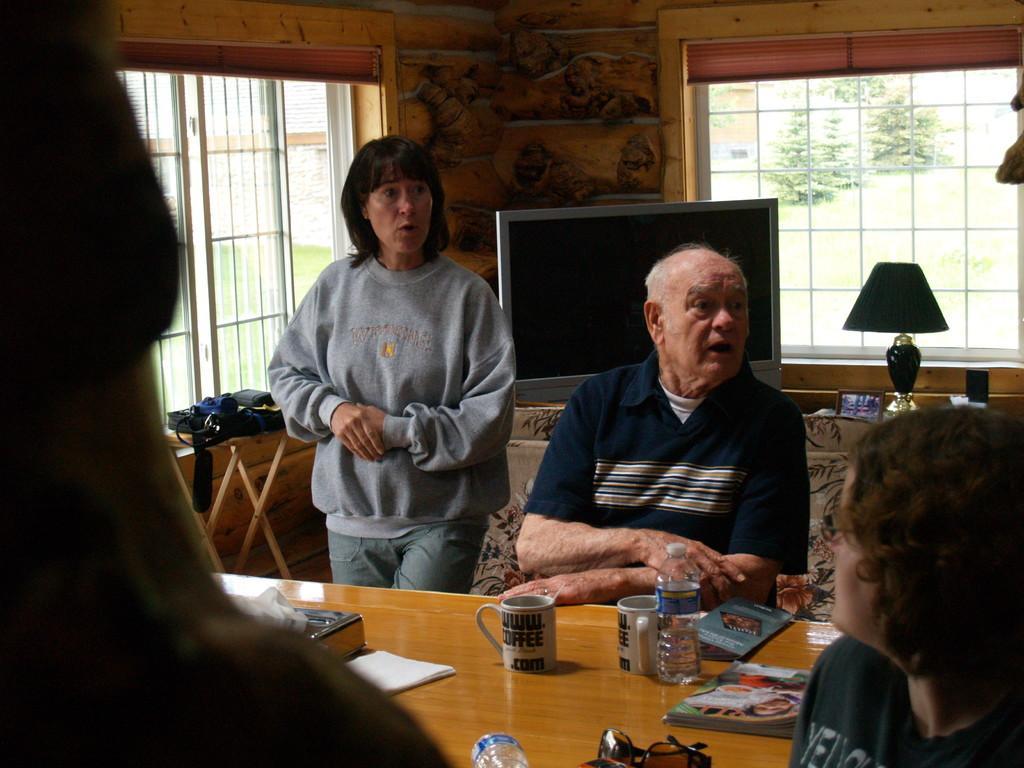In one or two sentences, can you explain what this image depicts? In this image, we can see few people. Few are standing and sitting. Here there is a wooden table. Few objects, cups, bottles are placed on it. Background we can see television, table, lamp, photo frame, big, wall, windows. Through the windows, we can see the outside view. Here we can see plants and grass. 